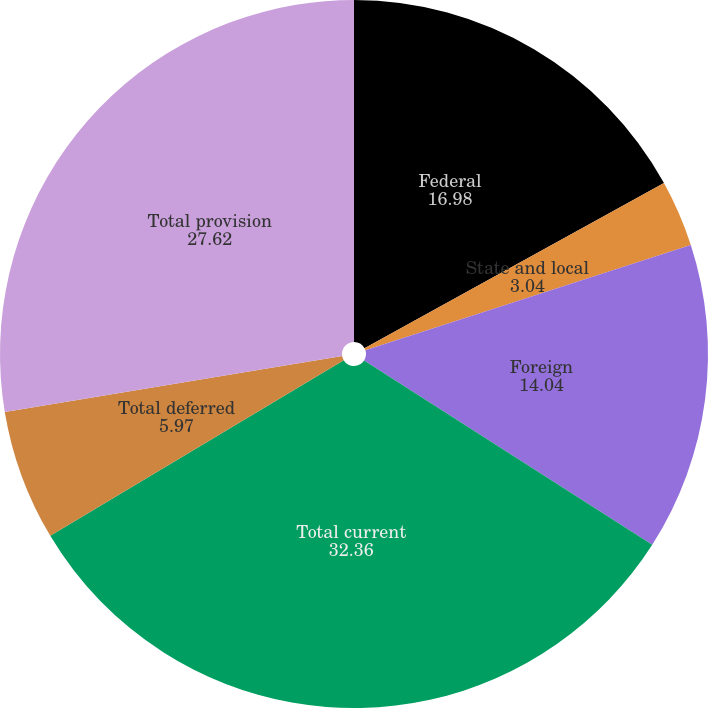Convert chart to OTSL. <chart><loc_0><loc_0><loc_500><loc_500><pie_chart><fcel>Federal<fcel>State and local<fcel>Foreign<fcel>Total current<fcel>Total deferred<fcel>Total provision<nl><fcel>16.98%<fcel>3.04%<fcel>14.04%<fcel>32.36%<fcel>5.97%<fcel>27.62%<nl></chart> 